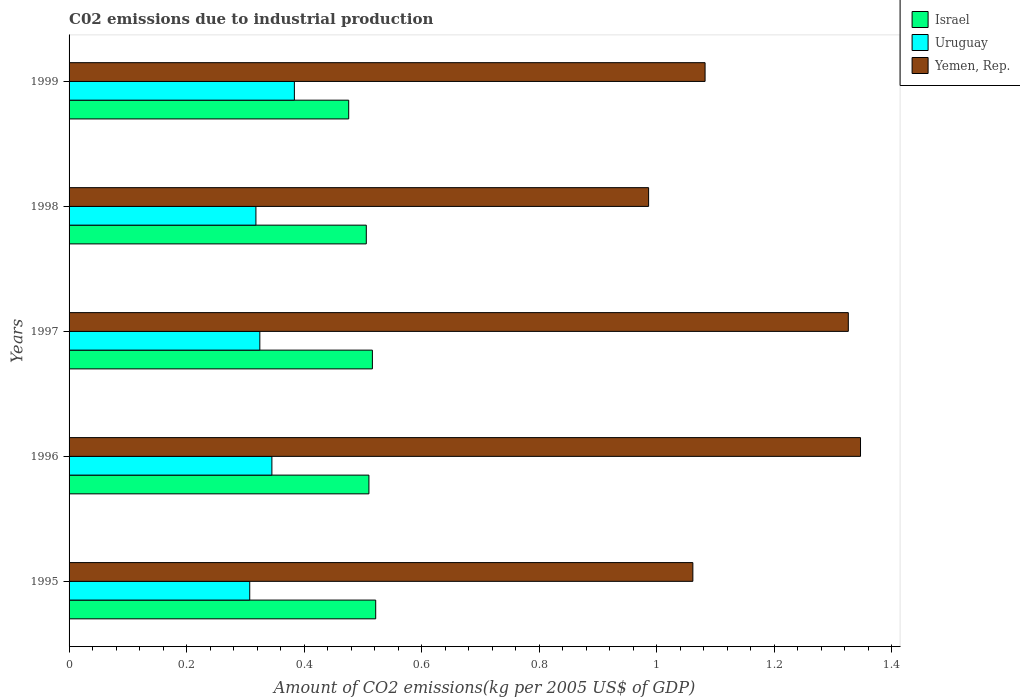How many different coloured bars are there?
Give a very brief answer. 3. How many groups of bars are there?
Make the answer very short. 5. Are the number of bars per tick equal to the number of legend labels?
Your answer should be compact. Yes. Are the number of bars on each tick of the Y-axis equal?
Provide a short and direct response. Yes. How many bars are there on the 1st tick from the bottom?
Your answer should be very brief. 3. What is the label of the 2nd group of bars from the top?
Provide a succinct answer. 1998. What is the amount of CO2 emitted due to industrial production in Israel in 1997?
Your response must be concise. 0.52. Across all years, what is the maximum amount of CO2 emitted due to industrial production in Israel?
Provide a short and direct response. 0.52. Across all years, what is the minimum amount of CO2 emitted due to industrial production in Uruguay?
Offer a terse response. 0.31. In which year was the amount of CO2 emitted due to industrial production in Yemen, Rep. maximum?
Your response must be concise. 1996. What is the total amount of CO2 emitted due to industrial production in Uruguay in the graph?
Provide a short and direct response. 1.68. What is the difference between the amount of CO2 emitted due to industrial production in Uruguay in 1995 and that in 1999?
Provide a short and direct response. -0.08. What is the difference between the amount of CO2 emitted due to industrial production in Yemen, Rep. in 1997 and the amount of CO2 emitted due to industrial production in Uruguay in 1999?
Your answer should be very brief. 0.94. What is the average amount of CO2 emitted due to industrial production in Uruguay per year?
Give a very brief answer. 0.34. In the year 1998, what is the difference between the amount of CO2 emitted due to industrial production in Uruguay and amount of CO2 emitted due to industrial production in Israel?
Offer a terse response. -0.19. What is the ratio of the amount of CO2 emitted due to industrial production in Yemen, Rep. in 1998 to that in 1999?
Offer a very short reply. 0.91. Is the amount of CO2 emitted due to industrial production in Israel in 1996 less than that in 1998?
Give a very brief answer. No. What is the difference between the highest and the second highest amount of CO2 emitted due to industrial production in Uruguay?
Keep it short and to the point. 0.04. What is the difference between the highest and the lowest amount of CO2 emitted due to industrial production in Uruguay?
Offer a terse response. 0.08. Is the sum of the amount of CO2 emitted due to industrial production in Yemen, Rep. in 1995 and 1999 greater than the maximum amount of CO2 emitted due to industrial production in Uruguay across all years?
Give a very brief answer. Yes. What does the 2nd bar from the bottom in 1998 represents?
Your answer should be very brief. Uruguay. How many bars are there?
Keep it short and to the point. 15. Are all the bars in the graph horizontal?
Offer a very short reply. Yes. How many years are there in the graph?
Provide a short and direct response. 5. What is the difference between two consecutive major ticks on the X-axis?
Provide a succinct answer. 0.2. Are the values on the major ticks of X-axis written in scientific E-notation?
Offer a very short reply. No. Does the graph contain grids?
Offer a terse response. No. How many legend labels are there?
Offer a very short reply. 3. What is the title of the graph?
Provide a short and direct response. C02 emissions due to industrial production. Does "Antigua and Barbuda" appear as one of the legend labels in the graph?
Your answer should be very brief. No. What is the label or title of the X-axis?
Offer a very short reply. Amount of CO2 emissions(kg per 2005 US$ of GDP). What is the Amount of CO2 emissions(kg per 2005 US$ of GDP) in Israel in 1995?
Make the answer very short. 0.52. What is the Amount of CO2 emissions(kg per 2005 US$ of GDP) of Uruguay in 1995?
Ensure brevity in your answer.  0.31. What is the Amount of CO2 emissions(kg per 2005 US$ of GDP) in Yemen, Rep. in 1995?
Give a very brief answer. 1.06. What is the Amount of CO2 emissions(kg per 2005 US$ of GDP) of Israel in 1996?
Make the answer very short. 0.51. What is the Amount of CO2 emissions(kg per 2005 US$ of GDP) of Uruguay in 1996?
Offer a very short reply. 0.35. What is the Amount of CO2 emissions(kg per 2005 US$ of GDP) of Yemen, Rep. in 1996?
Offer a very short reply. 1.35. What is the Amount of CO2 emissions(kg per 2005 US$ of GDP) of Israel in 1997?
Offer a terse response. 0.52. What is the Amount of CO2 emissions(kg per 2005 US$ of GDP) in Uruguay in 1997?
Ensure brevity in your answer.  0.32. What is the Amount of CO2 emissions(kg per 2005 US$ of GDP) in Yemen, Rep. in 1997?
Ensure brevity in your answer.  1.33. What is the Amount of CO2 emissions(kg per 2005 US$ of GDP) in Israel in 1998?
Your answer should be very brief. 0.51. What is the Amount of CO2 emissions(kg per 2005 US$ of GDP) in Uruguay in 1998?
Offer a very short reply. 0.32. What is the Amount of CO2 emissions(kg per 2005 US$ of GDP) of Yemen, Rep. in 1998?
Your answer should be very brief. 0.99. What is the Amount of CO2 emissions(kg per 2005 US$ of GDP) in Israel in 1999?
Your answer should be compact. 0.48. What is the Amount of CO2 emissions(kg per 2005 US$ of GDP) of Uruguay in 1999?
Keep it short and to the point. 0.38. What is the Amount of CO2 emissions(kg per 2005 US$ of GDP) in Yemen, Rep. in 1999?
Make the answer very short. 1.08. Across all years, what is the maximum Amount of CO2 emissions(kg per 2005 US$ of GDP) in Israel?
Offer a terse response. 0.52. Across all years, what is the maximum Amount of CO2 emissions(kg per 2005 US$ of GDP) in Uruguay?
Offer a very short reply. 0.38. Across all years, what is the maximum Amount of CO2 emissions(kg per 2005 US$ of GDP) of Yemen, Rep.?
Your answer should be compact. 1.35. Across all years, what is the minimum Amount of CO2 emissions(kg per 2005 US$ of GDP) in Israel?
Offer a terse response. 0.48. Across all years, what is the minimum Amount of CO2 emissions(kg per 2005 US$ of GDP) of Uruguay?
Ensure brevity in your answer.  0.31. Across all years, what is the minimum Amount of CO2 emissions(kg per 2005 US$ of GDP) in Yemen, Rep.?
Offer a terse response. 0.99. What is the total Amount of CO2 emissions(kg per 2005 US$ of GDP) in Israel in the graph?
Provide a short and direct response. 2.53. What is the total Amount of CO2 emissions(kg per 2005 US$ of GDP) of Uruguay in the graph?
Provide a short and direct response. 1.68. What is the total Amount of CO2 emissions(kg per 2005 US$ of GDP) of Yemen, Rep. in the graph?
Your answer should be compact. 5.8. What is the difference between the Amount of CO2 emissions(kg per 2005 US$ of GDP) in Israel in 1995 and that in 1996?
Ensure brevity in your answer.  0.01. What is the difference between the Amount of CO2 emissions(kg per 2005 US$ of GDP) in Uruguay in 1995 and that in 1996?
Give a very brief answer. -0.04. What is the difference between the Amount of CO2 emissions(kg per 2005 US$ of GDP) in Yemen, Rep. in 1995 and that in 1996?
Ensure brevity in your answer.  -0.29. What is the difference between the Amount of CO2 emissions(kg per 2005 US$ of GDP) of Israel in 1995 and that in 1997?
Provide a short and direct response. 0.01. What is the difference between the Amount of CO2 emissions(kg per 2005 US$ of GDP) in Uruguay in 1995 and that in 1997?
Keep it short and to the point. -0.02. What is the difference between the Amount of CO2 emissions(kg per 2005 US$ of GDP) of Yemen, Rep. in 1995 and that in 1997?
Offer a very short reply. -0.26. What is the difference between the Amount of CO2 emissions(kg per 2005 US$ of GDP) of Israel in 1995 and that in 1998?
Your answer should be compact. 0.02. What is the difference between the Amount of CO2 emissions(kg per 2005 US$ of GDP) of Uruguay in 1995 and that in 1998?
Your answer should be compact. -0.01. What is the difference between the Amount of CO2 emissions(kg per 2005 US$ of GDP) in Yemen, Rep. in 1995 and that in 1998?
Your response must be concise. 0.08. What is the difference between the Amount of CO2 emissions(kg per 2005 US$ of GDP) of Israel in 1995 and that in 1999?
Give a very brief answer. 0.05. What is the difference between the Amount of CO2 emissions(kg per 2005 US$ of GDP) of Uruguay in 1995 and that in 1999?
Give a very brief answer. -0.08. What is the difference between the Amount of CO2 emissions(kg per 2005 US$ of GDP) of Yemen, Rep. in 1995 and that in 1999?
Your answer should be compact. -0.02. What is the difference between the Amount of CO2 emissions(kg per 2005 US$ of GDP) in Israel in 1996 and that in 1997?
Provide a short and direct response. -0.01. What is the difference between the Amount of CO2 emissions(kg per 2005 US$ of GDP) of Uruguay in 1996 and that in 1997?
Provide a succinct answer. 0.02. What is the difference between the Amount of CO2 emissions(kg per 2005 US$ of GDP) in Yemen, Rep. in 1996 and that in 1997?
Your response must be concise. 0.02. What is the difference between the Amount of CO2 emissions(kg per 2005 US$ of GDP) of Israel in 1996 and that in 1998?
Ensure brevity in your answer.  0. What is the difference between the Amount of CO2 emissions(kg per 2005 US$ of GDP) of Uruguay in 1996 and that in 1998?
Offer a terse response. 0.03. What is the difference between the Amount of CO2 emissions(kg per 2005 US$ of GDP) in Yemen, Rep. in 1996 and that in 1998?
Offer a very short reply. 0.36. What is the difference between the Amount of CO2 emissions(kg per 2005 US$ of GDP) of Israel in 1996 and that in 1999?
Offer a terse response. 0.03. What is the difference between the Amount of CO2 emissions(kg per 2005 US$ of GDP) in Uruguay in 1996 and that in 1999?
Make the answer very short. -0.04. What is the difference between the Amount of CO2 emissions(kg per 2005 US$ of GDP) of Yemen, Rep. in 1996 and that in 1999?
Provide a succinct answer. 0.26. What is the difference between the Amount of CO2 emissions(kg per 2005 US$ of GDP) in Israel in 1997 and that in 1998?
Your answer should be very brief. 0.01. What is the difference between the Amount of CO2 emissions(kg per 2005 US$ of GDP) of Uruguay in 1997 and that in 1998?
Give a very brief answer. 0.01. What is the difference between the Amount of CO2 emissions(kg per 2005 US$ of GDP) of Yemen, Rep. in 1997 and that in 1998?
Offer a terse response. 0.34. What is the difference between the Amount of CO2 emissions(kg per 2005 US$ of GDP) of Israel in 1997 and that in 1999?
Ensure brevity in your answer.  0.04. What is the difference between the Amount of CO2 emissions(kg per 2005 US$ of GDP) in Uruguay in 1997 and that in 1999?
Give a very brief answer. -0.06. What is the difference between the Amount of CO2 emissions(kg per 2005 US$ of GDP) of Yemen, Rep. in 1997 and that in 1999?
Provide a short and direct response. 0.24. What is the difference between the Amount of CO2 emissions(kg per 2005 US$ of GDP) of Israel in 1998 and that in 1999?
Provide a short and direct response. 0.03. What is the difference between the Amount of CO2 emissions(kg per 2005 US$ of GDP) in Uruguay in 1998 and that in 1999?
Ensure brevity in your answer.  -0.07. What is the difference between the Amount of CO2 emissions(kg per 2005 US$ of GDP) of Yemen, Rep. in 1998 and that in 1999?
Your answer should be very brief. -0.1. What is the difference between the Amount of CO2 emissions(kg per 2005 US$ of GDP) in Israel in 1995 and the Amount of CO2 emissions(kg per 2005 US$ of GDP) in Uruguay in 1996?
Offer a terse response. 0.18. What is the difference between the Amount of CO2 emissions(kg per 2005 US$ of GDP) in Israel in 1995 and the Amount of CO2 emissions(kg per 2005 US$ of GDP) in Yemen, Rep. in 1996?
Keep it short and to the point. -0.82. What is the difference between the Amount of CO2 emissions(kg per 2005 US$ of GDP) in Uruguay in 1995 and the Amount of CO2 emissions(kg per 2005 US$ of GDP) in Yemen, Rep. in 1996?
Your answer should be compact. -1.04. What is the difference between the Amount of CO2 emissions(kg per 2005 US$ of GDP) in Israel in 1995 and the Amount of CO2 emissions(kg per 2005 US$ of GDP) in Uruguay in 1997?
Keep it short and to the point. 0.2. What is the difference between the Amount of CO2 emissions(kg per 2005 US$ of GDP) in Israel in 1995 and the Amount of CO2 emissions(kg per 2005 US$ of GDP) in Yemen, Rep. in 1997?
Offer a very short reply. -0.8. What is the difference between the Amount of CO2 emissions(kg per 2005 US$ of GDP) of Uruguay in 1995 and the Amount of CO2 emissions(kg per 2005 US$ of GDP) of Yemen, Rep. in 1997?
Keep it short and to the point. -1.02. What is the difference between the Amount of CO2 emissions(kg per 2005 US$ of GDP) in Israel in 1995 and the Amount of CO2 emissions(kg per 2005 US$ of GDP) in Uruguay in 1998?
Keep it short and to the point. 0.2. What is the difference between the Amount of CO2 emissions(kg per 2005 US$ of GDP) in Israel in 1995 and the Amount of CO2 emissions(kg per 2005 US$ of GDP) in Yemen, Rep. in 1998?
Your answer should be very brief. -0.46. What is the difference between the Amount of CO2 emissions(kg per 2005 US$ of GDP) in Uruguay in 1995 and the Amount of CO2 emissions(kg per 2005 US$ of GDP) in Yemen, Rep. in 1998?
Provide a succinct answer. -0.68. What is the difference between the Amount of CO2 emissions(kg per 2005 US$ of GDP) in Israel in 1995 and the Amount of CO2 emissions(kg per 2005 US$ of GDP) in Uruguay in 1999?
Your response must be concise. 0.14. What is the difference between the Amount of CO2 emissions(kg per 2005 US$ of GDP) in Israel in 1995 and the Amount of CO2 emissions(kg per 2005 US$ of GDP) in Yemen, Rep. in 1999?
Provide a short and direct response. -0.56. What is the difference between the Amount of CO2 emissions(kg per 2005 US$ of GDP) in Uruguay in 1995 and the Amount of CO2 emissions(kg per 2005 US$ of GDP) in Yemen, Rep. in 1999?
Make the answer very short. -0.77. What is the difference between the Amount of CO2 emissions(kg per 2005 US$ of GDP) in Israel in 1996 and the Amount of CO2 emissions(kg per 2005 US$ of GDP) in Uruguay in 1997?
Your response must be concise. 0.19. What is the difference between the Amount of CO2 emissions(kg per 2005 US$ of GDP) of Israel in 1996 and the Amount of CO2 emissions(kg per 2005 US$ of GDP) of Yemen, Rep. in 1997?
Your answer should be very brief. -0.82. What is the difference between the Amount of CO2 emissions(kg per 2005 US$ of GDP) in Uruguay in 1996 and the Amount of CO2 emissions(kg per 2005 US$ of GDP) in Yemen, Rep. in 1997?
Keep it short and to the point. -0.98. What is the difference between the Amount of CO2 emissions(kg per 2005 US$ of GDP) in Israel in 1996 and the Amount of CO2 emissions(kg per 2005 US$ of GDP) in Uruguay in 1998?
Offer a very short reply. 0.19. What is the difference between the Amount of CO2 emissions(kg per 2005 US$ of GDP) of Israel in 1996 and the Amount of CO2 emissions(kg per 2005 US$ of GDP) of Yemen, Rep. in 1998?
Offer a terse response. -0.48. What is the difference between the Amount of CO2 emissions(kg per 2005 US$ of GDP) in Uruguay in 1996 and the Amount of CO2 emissions(kg per 2005 US$ of GDP) in Yemen, Rep. in 1998?
Provide a succinct answer. -0.64. What is the difference between the Amount of CO2 emissions(kg per 2005 US$ of GDP) in Israel in 1996 and the Amount of CO2 emissions(kg per 2005 US$ of GDP) in Uruguay in 1999?
Provide a succinct answer. 0.13. What is the difference between the Amount of CO2 emissions(kg per 2005 US$ of GDP) of Israel in 1996 and the Amount of CO2 emissions(kg per 2005 US$ of GDP) of Yemen, Rep. in 1999?
Give a very brief answer. -0.57. What is the difference between the Amount of CO2 emissions(kg per 2005 US$ of GDP) in Uruguay in 1996 and the Amount of CO2 emissions(kg per 2005 US$ of GDP) in Yemen, Rep. in 1999?
Your answer should be very brief. -0.74. What is the difference between the Amount of CO2 emissions(kg per 2005 US$ of GDP) of Israel in 1997 and the Amount of CO2 emissions(kg per 2005 US$ of GDP) of Uruguay in 1998?
Ensure brevity in your answer.  0.2. What is the difference between the Amount of CO2 emissions(kg per 2005 US$ of GDP) in Israel in 1997 and the Amount of CO2 emissions(kg per 2005 US$ of GDP) in Yemen, Rep. in 1998?
Provide a short and direct response. -0.47. What is the difference between the Amount of CO2 emissions(kg per 2005 US$ of GDP) in Uruguay in 1997 and the Amount of CO2 emissions(kg per 2005 US$ of GDP) in Yemen, Rep. in 1998?
Offer a terse response. -0.66. What is the difference between the Amount of CO2 emissions(kg per 2005 US$ of GDP) in Israel in 1997 and the Amount of CO2 emissions(kg per 2005 US$ of GDP) in Uruguay in 1999?
Keep it short and to the point. 0.13. What is the difference between the Amount of CO2 emissions(kg per 2005 US$ of GDP) in Israel in 1997 and the Amount of CO2 emissions(kg per 2005 US$ of GDP) in Yemen, Rep. in 1999?
Make the answer very short. -0.57. What is the difference between the Amount of CO2 emissions(kg per 2005 US$ of GDP) of Uruguay in 1997 and the Amount of CO2 emissions(kg per 2005 US$ of GDP) of Yemen, Rep. in 1999?
Your response must be concise. -0.76. What is the difference between the Amount of CO2 emissions(kg per 2005 US$ of GDP) in Israel in 1998 and the Amount of CO2 emissions(kg per 2005 US$ of GDP) in Uruguay in 1999?
Provide a succinct answer. 0.12. What is the difference between the Amount of CO2 emissions(kg per 2005 US$ of GDP) of Israel in 1998 and the Amount of CO2 emissions(kg per 2005 US$ of GDP) of Yemen, Rep. in 1999?
Provide a short and direct response. -0.58. What is the difference between the Amount of CO2 emissions(kg per 2005 US$ of GDP) in Uruguay in 1998 and the Amount of CO2 emissions(kg per 2005 US$ of GDP) in Yemen, Rep. in 1999?
Your answer should be very brief. -0.76. What is the average Amount of CO2 emissions(kg per 2005 US$ of GDP) in Israel per year?
Your answer should be very brief. 0.51. What is the average Amount of CO2 emissions(kg per 2005 US$ of GDP) of Uruguay per year?
Your answer should be very brief. 0.34. What is the average Amount of CO2 emissions(kg per 2005 US$ of GDP) of Yemen, Rep. per year?
Ensure brevity in your answer.  1.16. In the year 1995, what is the difference between the Amount of CO2 emissions(kg per 2005 US$ of GDP) in Israel and Amount of CO2 emissions(kg per 2005 US$ of GDP) in Uruguay?
Make the answer very short. 0.21. In the year 1995, what is the difference between the Amount of CO2 emissions(kg per 2005 US$ of GDP) of Israel and Amount of CO2 emissions(kg per 2005 US$ of GDP) of Yemen, Rep.?
Provide a succinct answer. -0.54. In the year 1995, what is the difference between the Amount of CO2 emissions(kg per 2005 US$ of GDP) of Uruguay and Amount of CO2 emissions(kg per 2005 US$ of GDP) of Yemen, Rep.?
Give a very brief answer. -0.75. In the year 1996, what is the difference between the Amount of CO2 emissions(kg per 2005 US$ of GDP) in Israel and Amount of CO2 emissions(kg per 2005 US$ of GDP) in Uruguay?
Your response must be concise. 0.17. In the year 1996, what is the difference between the Amount of CO2 emissions(kg per 2005 US$ of GDP) of Israel and Amount of CO2 emissions(kg per 2005 US$ of GDP) of Yemen, Rep.?
Your response must be concise. -0.84. In the year 1996, what is the difference between the Amount of CO2 emissions(kg per 2005 US$ of GDP) in Uruguay and Amount of CO2 emissions(kg per 2005 US$ of GDP) in Yemen, Rep.?
Give a very brief answer. -1. In the year 1997, what is the difference between the Amount of CO2 emissions(kg per 2005 US$ of GDP) in Israel and Amount of CO2 emissions(kg per 2005 US$ of GDP) in Uruguay?
Your response must be concise. 0.19. In the year 1997, what is the difference between the Amount of CO2 emissions(kg per 2005 US$ of GDP) of Israel and Amount of CO2 emissions(kg per 2005 US$ of GDP) of Yemen, Rep.?
Make the answer very short. -0.81. In the year 1997, what is the difference between the Amount of CO2 emissions(kg per 2005 US$ of GDP) of Uruguay and Amount of CO2 emissions(kg per 2005 US$ of GDP) of Yemen, Rep.?
Keep it short and to the point. -1. In the year 1998, what is the difference between the Amount of CO2 emissions(kg per 2005 US$ of GDP) in Israel and Amount of CO2 emissions(kg per 2005 US$ of GDP) in Uruguay?
Offer a very short reply. 0.19. In the year 1998, what is the difference between the Amount of CO2 emissions(kg per 2005 US$ of GDP) in Israel and Amount of CO2 emissions(kg per 2005 US$ of GDP) in Yemen, Rep.?
Your response must be concise. -0.48. In the year 1998, what is the difference between the Amount of CO2 emissions(kg per 2005 US$ of GDP) of Uruguay and Amount of CO2 emissions(kg per 2005 US$ of GDP) of Yemen, Rep.?
Your answer should be compact. -0.67. In the year 1999, what is the difference between the Amount of CO2 emissions(kg per 2005 US$ of GDP) of Israel and Amount of CO2 emissions(kg per 2005 US$ of GDP) of Uruguay?
Your response must be concise. 0.09. In the year 1999, what is the difference between the Amount of CO2 emissions(kg per 2005 US$ of GDP) of Israel and Amount of CO2 emissions(kg per 2005 US$ of GDP) of Yemen, Rep.?
Your answer should be compact. -0.61. In the year 1999, what is the difference between the Amount of CO2 emissions(kg per 2005 US$ of GDP) of Uruguay and Amount of CO2 emissions(kg per 2005 US$ of GDP) of Yemen, Rep.?
Make the answer very short. -0.7. What is the ratio of the Amount of CO2 emissions(kg per 2005 US$ of GDP) in Israel in 1995 to that in 1996?
Ensure brevity in your answer.  1.02. What is the ratio of the Amount of CO2 emissions(kg per 2005 US$ of GDP) in Uruguay in 1995 to that in 1996?
Ensure brevity in your answer.  0.89. What is the ratio of the Amount of CO2 emissions(kg per 2005 US$ of GDP) of Yemen, Rep. in 1995 to that in 1996?
Your answer should be very brief. 0.79. What is the ratio of the Amount of CO2 emissions(kg per 2005 US$ of GDP) of Israel in 1995 to that in 1997?
Keep it short and to the point. 1.01. What is the ratio of the Amount of CO2 emissions(kg per 2005 US$ of GDP) in Uruguay in 1995 to that in 1997?
Offer a terse response. 0.95. What is the ratio of the Amount of CO2 emissions(kg per 2005 US$ of GDP) in Yemen, Rep. in 1995 to that in 1997?
Provide a succinct answer. 0.8. What is the ratio of the Amount of CO2 emissions(kg per 2005 US$ of GDP) in Israel in 1995 to that in 1998?
Make the answer very short. 1.03. What is the ratio of the Amount of CO2 emissions(kg per 2005 US$ of GDP) of Uruguay in 1995 to that in 1998?
Offer a very short reply. 0.97. What is the ratio of the Amount of CO2 emissions(kg per 2005 US$ of GDP) of Yemen, Rep. in 1995 to that in 1998?
Ensure brevity in your answer.  1.08. What is the ratio of the Amount of CO2 emissions(kg per 2005 US$ of GDP) in Israel in 1995 to that in 1999?
Your answer should be very brief. 1.1. What is the ratio of the Amount of CO2 emissions(kg per 2005 US$ of GDP) in Uruguay in 1995 to that in 1999?
Give a very brief answer. 0.8. What is the ratio of the Amount of CO2 emissions(kg per 2005 US$ of GDP) of Yemen, Rep. in 1995 to that in 1999?
Your response must be concise. 0.98. What is the ratio of the Amount of CO2 emissions(kg per 2005 US$ of GDP) of Uruguay in 1996 to that in 1997?
Keep it short and to the point. 1.06. What is the ratio of the Amount of CO2 emissions(kg per 2005 US$ of GDP) in Yemen, Rep. in 1996 to that in 1997?
Your response must be concise. 1.02. What is the ratio of the Amount of CO2 emissions(kg per 2005 US$ of GDP) of Israel in 1996 to that in 1998?
Offer a very short reply. 1.01. What is the ratio of the Amount of CO2 emissions(kg per 2005 US$ of GDP) of Uruguay in 1996 to that in 1998?
Ensure brevity in your answer.  1.09. What is the ratio of the Amount of CO2 emissions(kg per 2005 US$ of GDP) in Yemen, Rep. in 1996 to that in 1998?
Keep it short and to the point. 1.37. What is the ratio of the Amount of CO2 emissions(kg per 2005 US$ of GDP) in Israel in 1996 to that in 1999?
Give a very brief answer. 1.07. What is the ratio of the Amount of CO2 emissions(kg per 2005 US$ of GDP) in Uruguay in 1996 to that in 1999?
Give a very brief answer. 0.9. What is the ratio of the Amount of CO2 emissions(kg per 2005 US$ of GDP) of Yemen, Rep. in 1996 to that in 1999?
Your answer should be very brief. 1.24. What is the ratio of the Amount of CO2 emissions(kg per 2005 US$ of GDP) in Israel in 1997 to that in 1998?
Your response must be concise. 1.02. What is the ratio of the Amount of CO2 emissions(kg per 2005 US$ of GDP) of Uruguay in 1997 to that in 1998?
Make the answer very short. 1.02. What is the ratio of the Amount of CO2 emissions(kg per 2005 US$ of GDP) in Yemen, Rep. in 1997 to that in 1998?
Make the answer very short. 1.34. What is the ratio of the Amount of CO2 emissions(kg per 2005 US$ of GDP) in Israel in 1997 to that in 1999?
Provide a short and direct response. 1.08. What is the ratio of the Amount of CO2 emissions(kg per 2005 US$ of GDP) in Uruguay in 1997 to that in 1999?
Give a very brief answer. 0.85. What is the ratio of the Amount of CO2 emissions(kg per 2005 US$ of GDP) in Yemen, Rep. in 1997 to that in 1999?
Your answer should be compact. 1.23. What is the ratio of the Amount of CO2 emissions(kg per 2005 US$ of GDP) in Israel in 1998 to that in 1999?
Keep it short and to the point. 1.06. What is the ratio of the Amount of CO2 emissions(kg per 2005 US$ of GDP) of Uruguay in 1998 to that in 1999?
Ensure brevity in your answer.  0.83. What is the ratio of the Amount of CO2 emissions(kg per 2005 US$ of GDP) in Yemen, Rep. in 1998 to that in 1999?
Provide a short and direct response. 0.91. What is the difference between the highest and the second highest Amount of CO2 emissions(kg per 2005 US$ of GDP) in Israel?
Your answer should be compact. 0.01. What is the difference between the highest and the second highest Amount of CO2 emissions(kg per 2005 US$ of GDP) in Uruguay?
Offer a terse response. 0.04. What is the difference between the highest and the second highest Amount of CO2 emissions(kg per 2005 US$ of GDP) in Yemen, Rep.?
Your answer should be very brief. 0.02. What is the difference between the highest and the lowest Amount of CO2 emissions(kg per 2005 US$ of GDP) of Israel?
Ensure brevity in your answer.  0.05. What is the difference between the highest and the lowest Amount of CO2 emissions(kg per 2005 US$ of GDP) of Uruguay?
Offer a terse response. 0.08. What is the difference between the highest and the lowest Amount of CO2 emissions(kg per 2005 US$ of GDP) in Yemen, Rep.?
Keep it short and to the point. 0.36. 